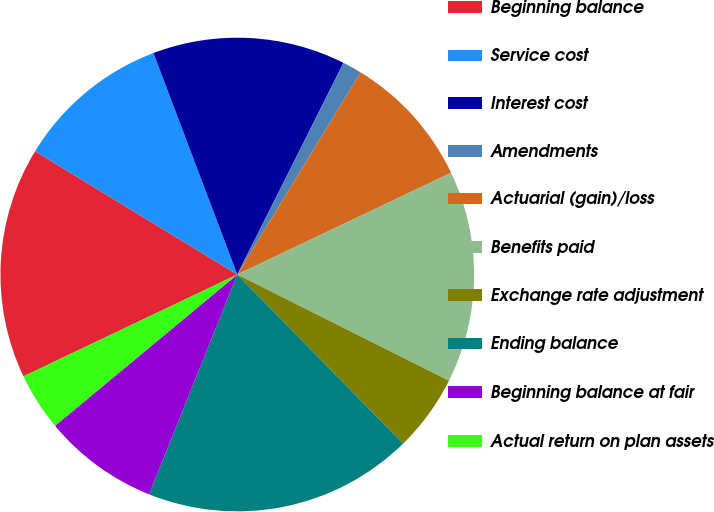<chart> <loc_0><loc_0><loc_500><loc_500><pie_chart><fcel>Beginning balance<fcel>Service cost<fcel>Interest cost<fcel>Amendments<fcel>Actuarial (gain)/loss<fcel>Benefits paid<fcel>Exchange rate adjustment<fcel>Ending balance<fcel>Beginning balance at fair<fcel>Actual return on plan assets<nl><fcel>15.79%<fcel>10.53%<fcel>13.16%<fcel>1.32%<fcel>9.21%<fcel>14.47%<fcel>5.26%<fcel>18.42%<fcel>7.9%<fcel>3.95%<nl></chart> 